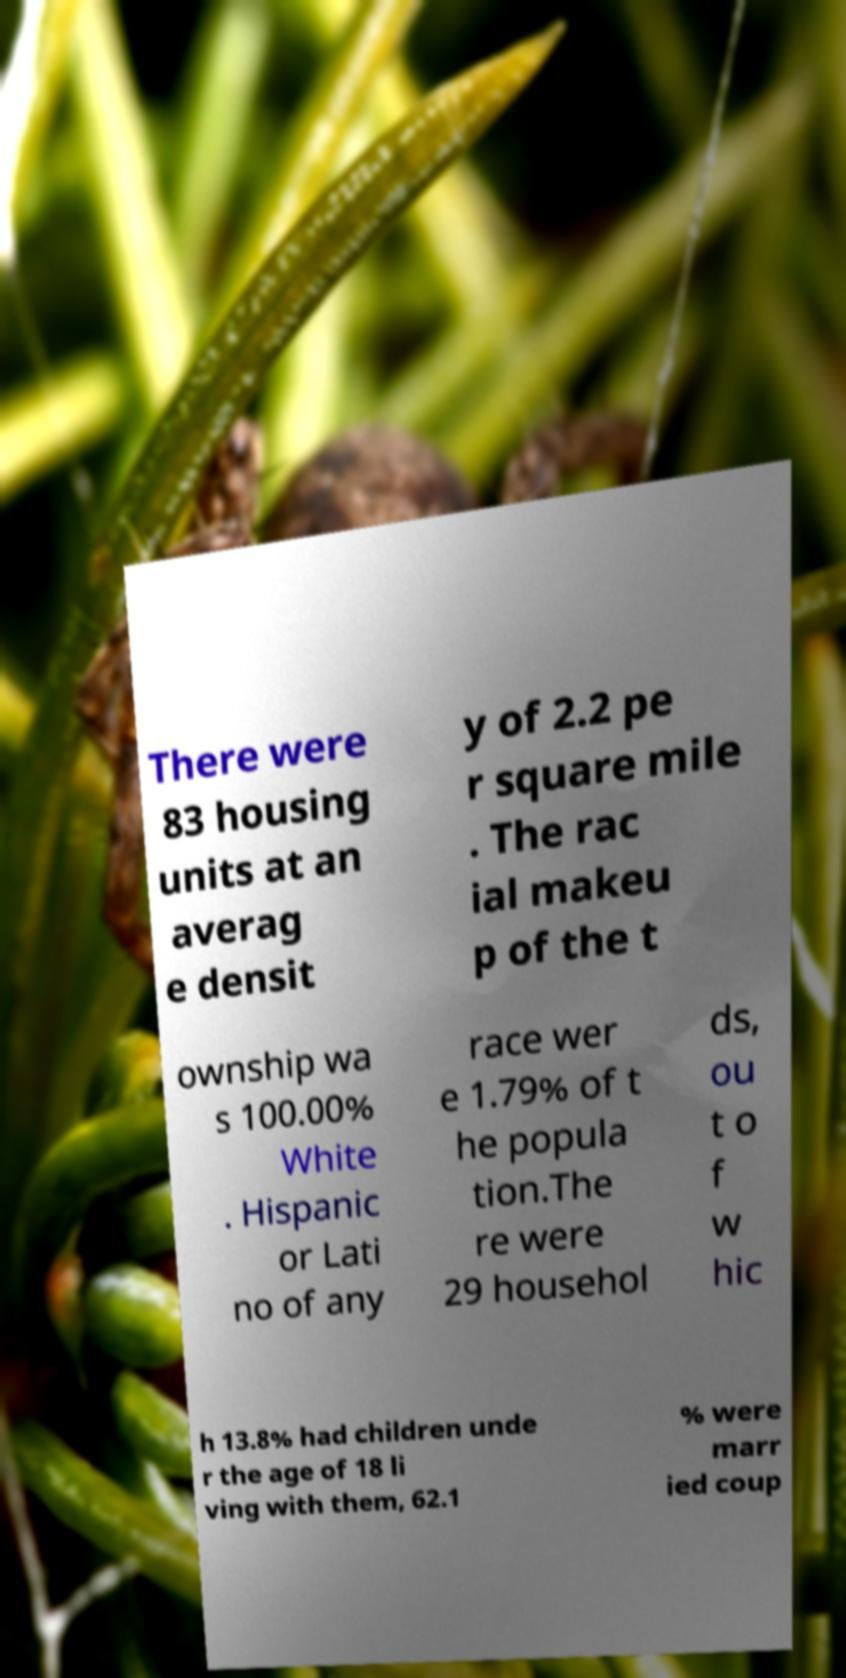There's text embedded in this image that I need extracted. Can you transcribe it verbatim? There were 83 housing units at an averag e densit y of 2.2 pe r square mile . The rac ial makeu p of the t ownship wa s 100.00% White . Hispanic or Lati no of any race wer e 1.79% of t he popula tion.The re were 29 househol ds, ou t o f w hic h 13.8% had children unde r the age of 18 li ving with them, 62.1 % were marr ied coup 